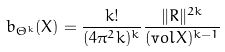Convert formula to latex. <formula><loc_0><loc_0><loc_500><loc_500>b _ { \Theta ^ { k } } ( X ) = \frac { k ! } { ( 4 \pi ^ { 2 } k ) ^ { k } } \frac { \| R \| ^ { 2 k } } { ( { \mathrm v o l } X ) ^ { k - 1 } }</formula> 